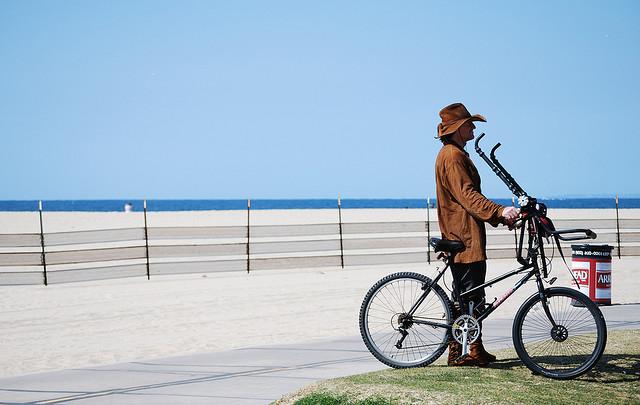Is the man a bmx biker?
Keep it brief. No. Do the tops of the posts meet the horizon line?
Write a very short answer. Yes. How many methods of transportation are shown?
Quick response, please. 1. What is behind the people?
Write a very short answer. Ocean. Do the colors of the bike pop in this beach scene?
Short answer required. No. What is the can used for?
Short answer required. Trash. 